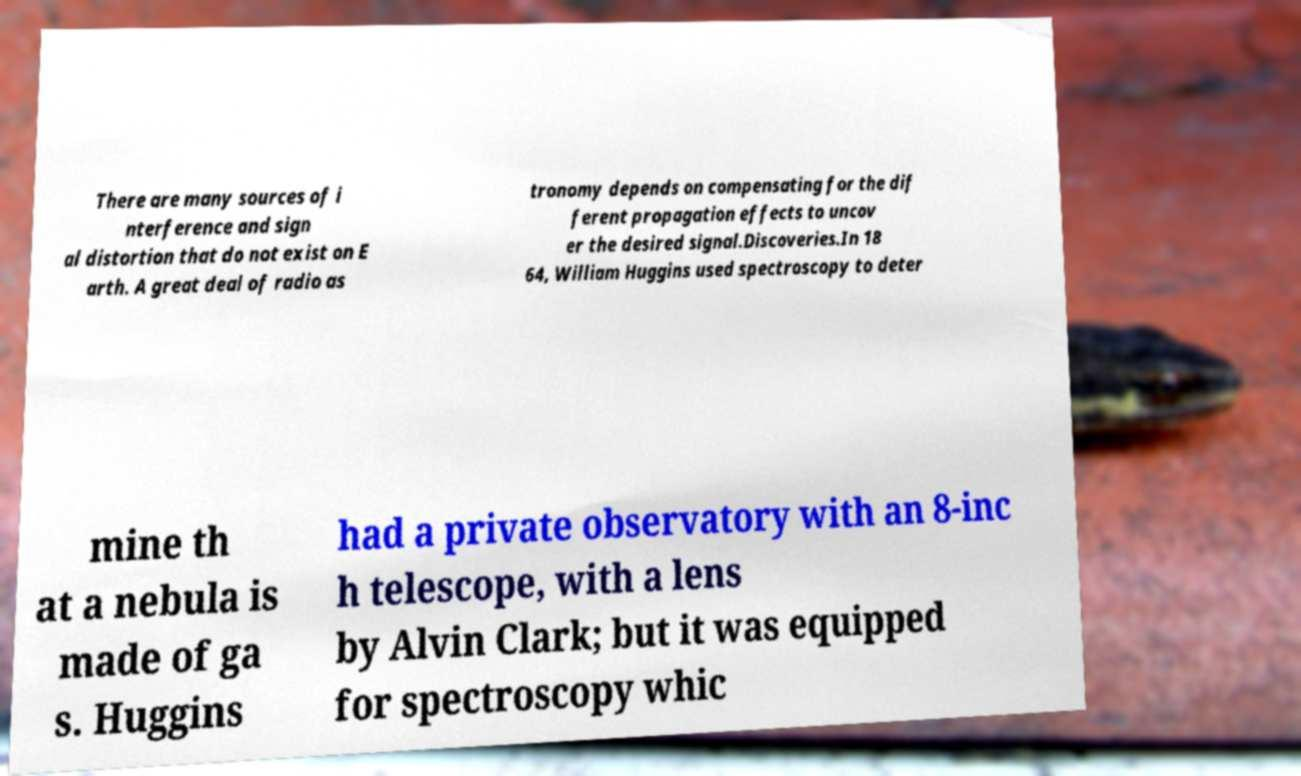Can you accurately transcribe the text from the provided image for me? There are many sources of i nterference and sign al distortion that do not exist on E arth. A great deal of radio as tronomy depends on compensating for the dif ferent propagation effects to uncov er the desired signal.Discoveries.In 18 64, William Huggins used spectroscopy to deter mine th at a nebula is made of ga s. Huggins had a private observatory with an 8-inc h telescope, with a lens by Alvin Clark; but it was equipped for spectroscopy whic 